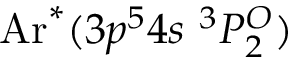Convert formula to latex. <formula><loc_0><loc_0><loc_500><loc_500>A r ^ { * } ( 3 p ^ { 5 } 4 s \ ^ { 3 } P _ { 2 } ^ { O } )</formula> 